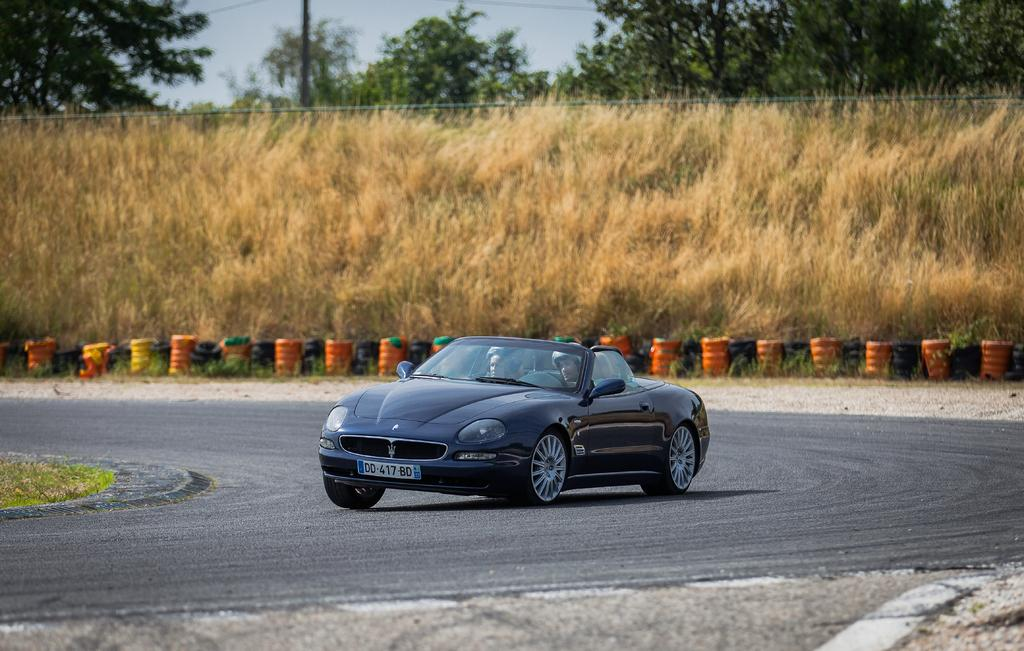What is on the road in the image? There is a car on the road in the image. What can be seen in the background of the image? There are trees visible in the image. What type of shelf can be seen in the image? There is no shelf present in the image. What sense is being stimulated by the image? The image is primarily visual, stimulating the sense of sight. 